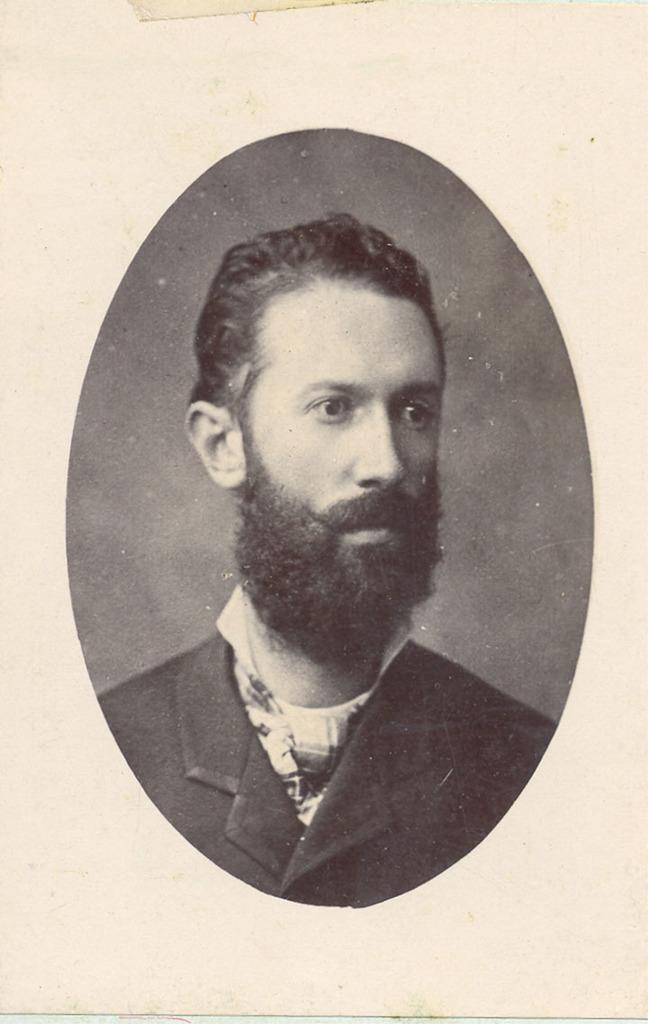In one or two sentences, can you explain what this image depicts? This is a black and white image of a man wearing black coat. 